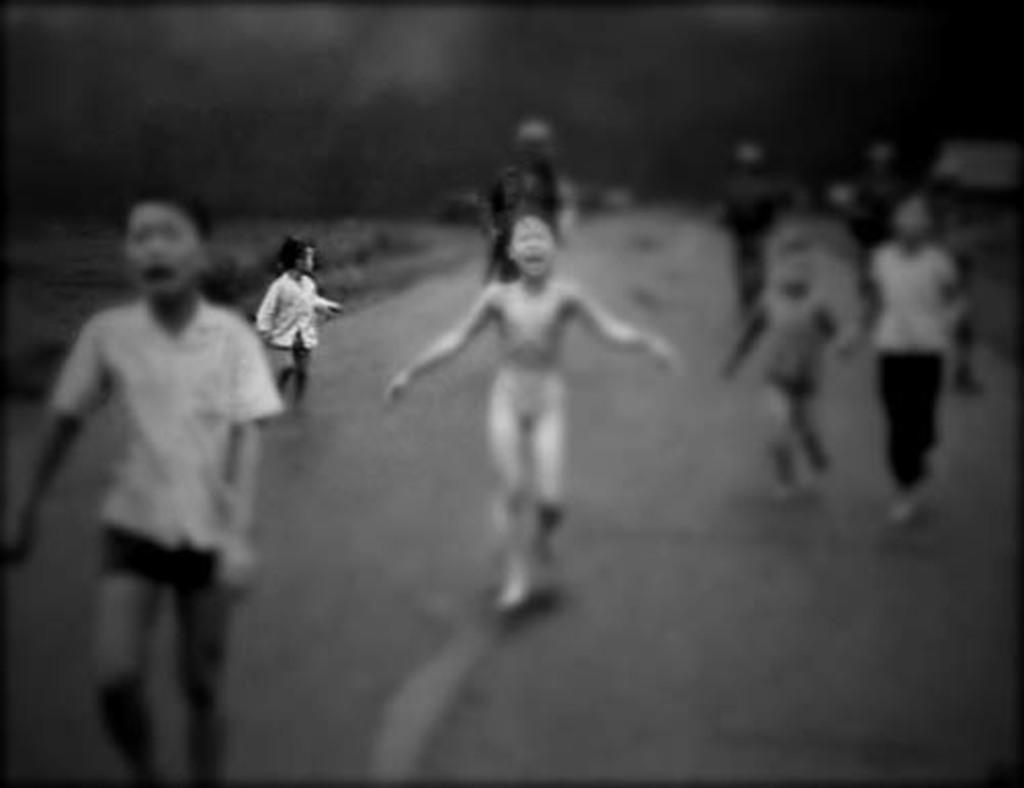Who or what is present in the image? There are people in the image. What type of surface can be seen beneath the people? There is grass in the image. Can you describe the background of the image? The background of the image is blurred. How would you describe the lighting in the image? The image is slightly dark. What type of account is being discussed in the image? There is no account being discussed in the image; it features people and grass. Is there a paper visible in the image? There is no paper visible in the image. 